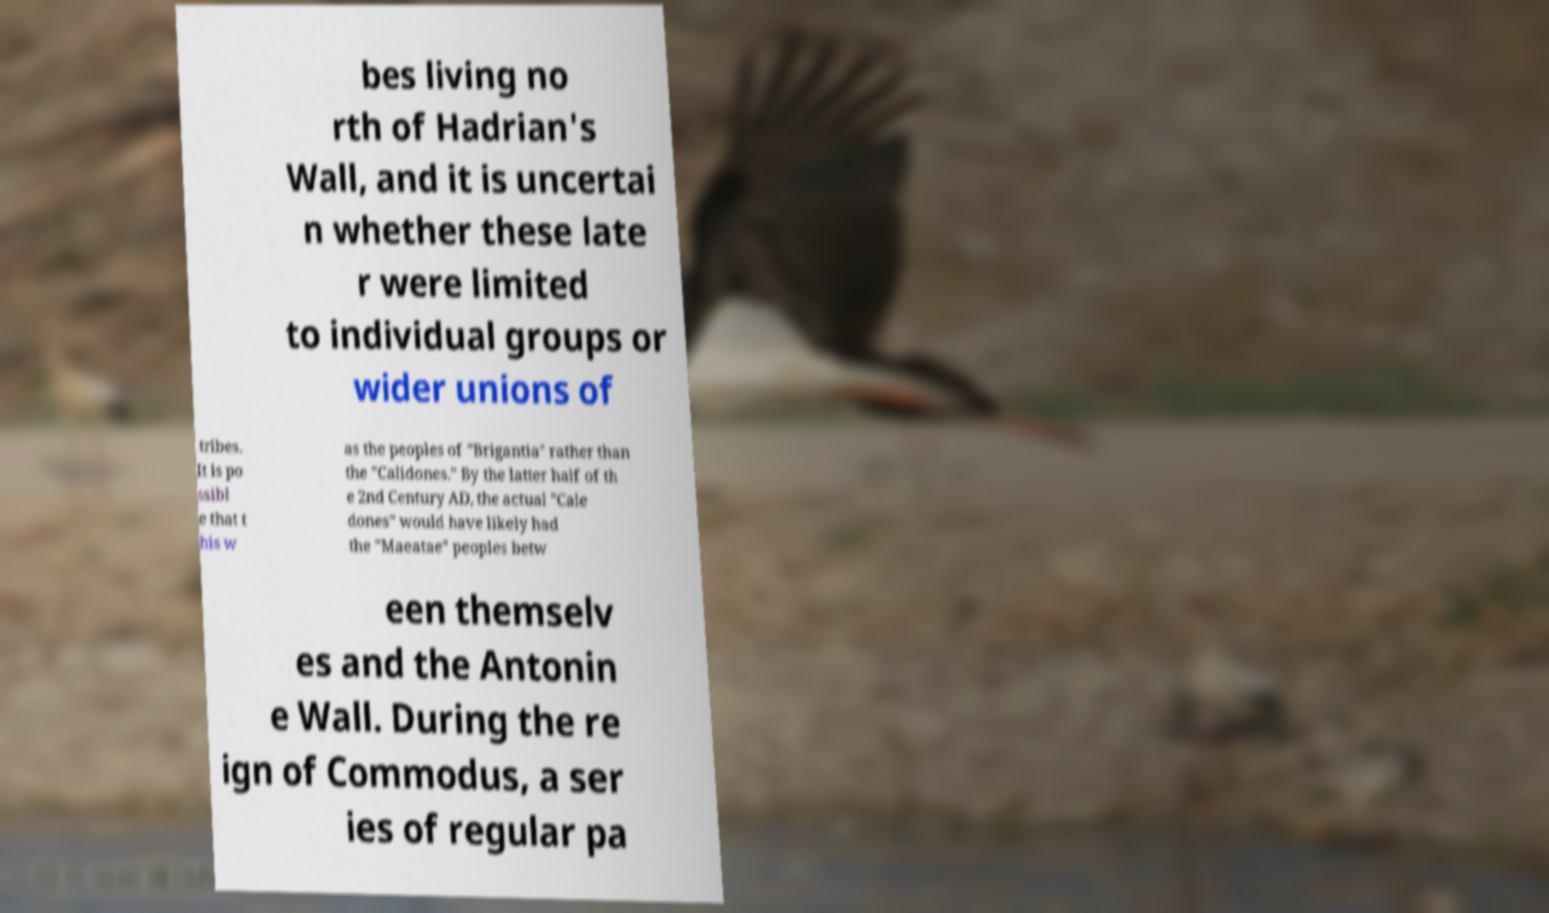For documentation purposes, I need the text within this image transcribed. Could you provide that? bes living no rth of Hadrian's Wall, and it is uncertai n whether these late r were limited to individual groups or wider unions of tribes. It is po ssibl e that t his w as the peoples of "Brigantia" rather than the "Calidones." By the latter half of th e 2nd Century AD, the actual "Cale dones" would have likely had the "Maeatae" peoples betw een themselv es and the Antonin e Wall. During the re ign of Commodus, a ser ies of regular pa 